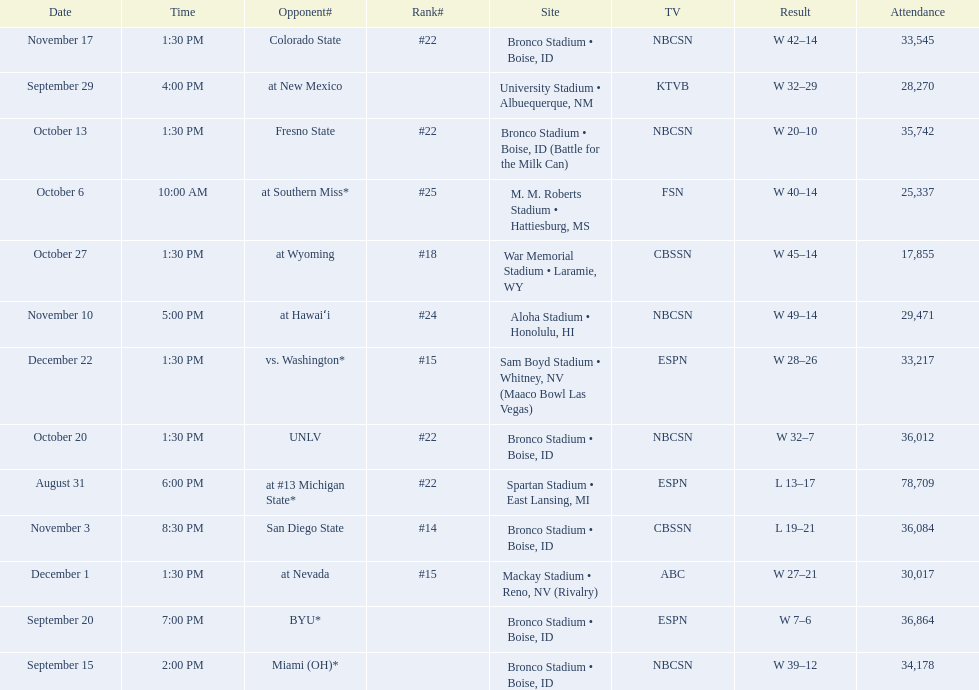What are the opponent teams of the 2012 boise state broncos football team? At #13 michigan state*, miami (oh)*, byu*, at new mexico, at southern miss*, fresno state, unlv, at wyoming, san diego state, at hawaiʻi, colorado state, at nevada, vs. washington*. How has the highest rank of these opponents? San Diego State. 